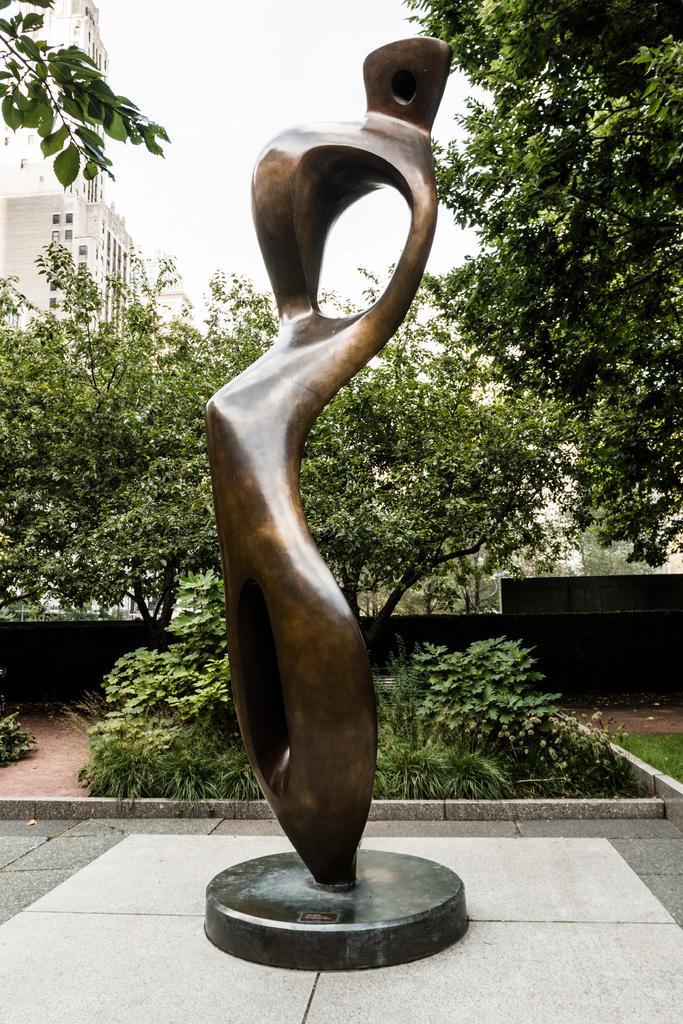Could you give a brief overview of what you see in this image? In this picture It looks like a statue in the middle, in the background I can see the trees and buildings. At the top there is the sky. 